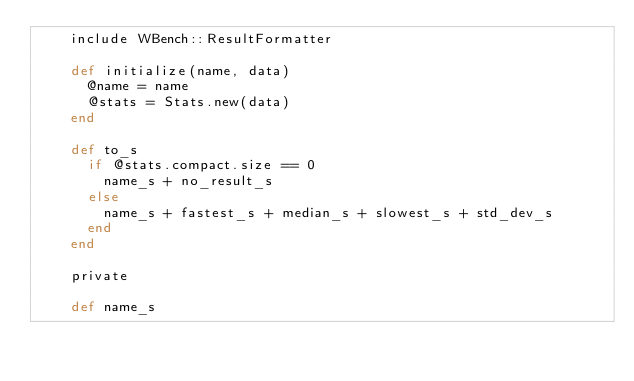Convert code to text. <code><loc_0><loc_0><loc_500><loc_500><_Ruby_>    include WBench::ResultFormatter

    def initialize(name, data)
      @name = name
      @stats = Stats.new(data)
    end

    def to_s
      if @stats.compact.size == 0
        name_s + no_result_s
      else
        name_s + fastest_s + median_s + slowest_s + std_dev_s
      end
    end

    private

    def name_s</code> 